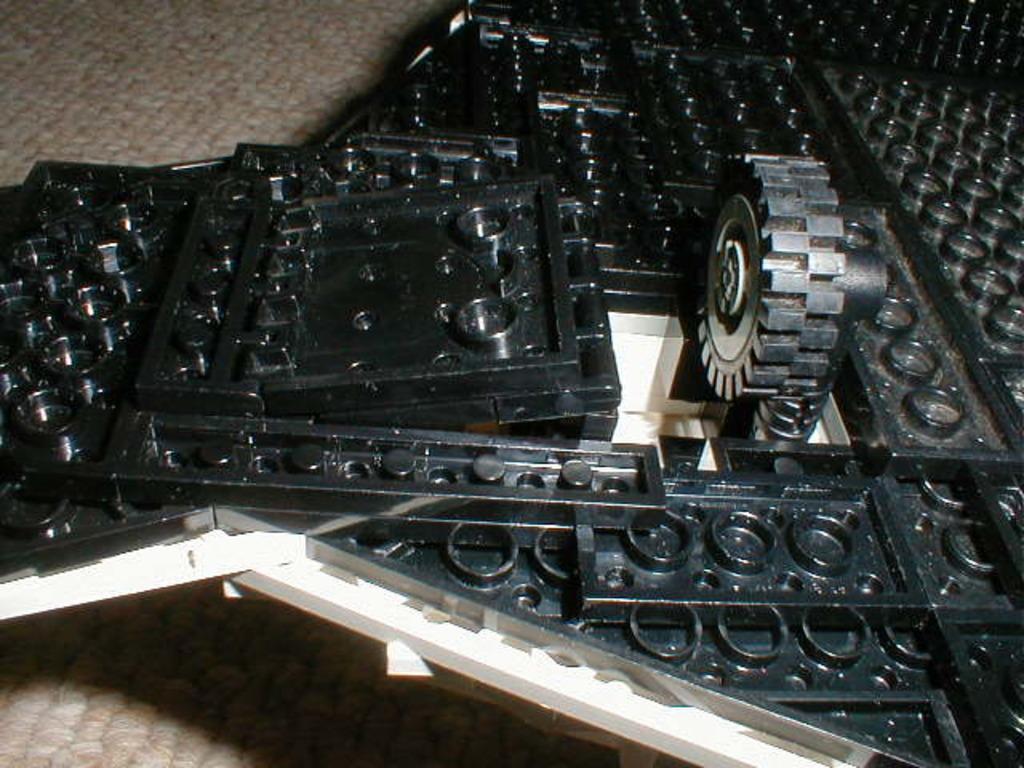How would you summarize this image in a sentence or two? In this picture I can see there is a black frame and a wheel. It is placed on the cream color surface. 